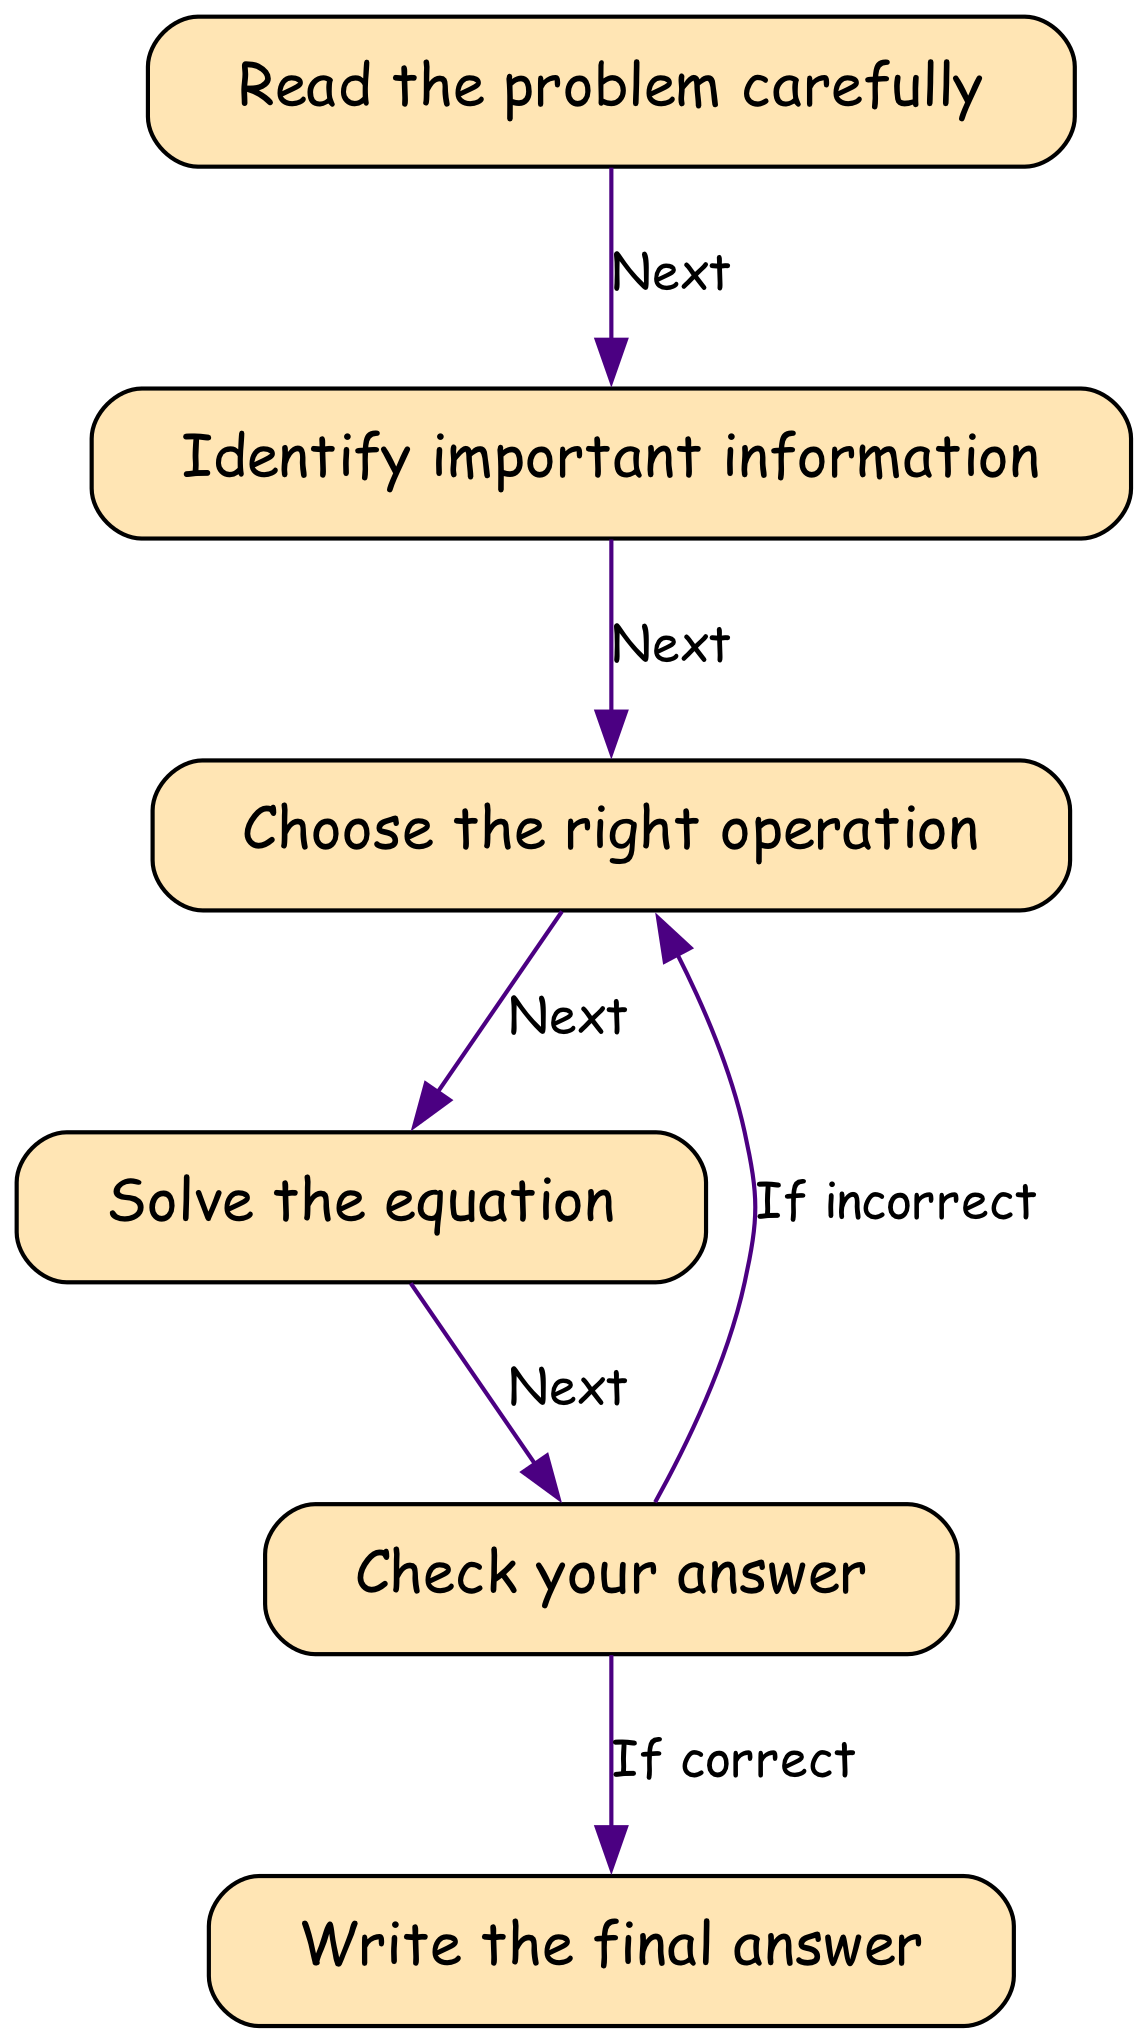What is the first step in the flowchart? The first node in the flowchart is labeled "Read the problem carefully," indicating the initial action to take when solving a math word problem.
Answer: Read the problem carefully How many total nodes are in the diagram? By counting each distinct node in the flowchart, we identify six nodes: start, identify, choose, solve, check, and end.
Answer: Six What does the edge from 'check' to 'end' indicate? The edge labeled "If correct" coming from the 'check' node leads to 'end,' which signifies that if the answer checked is correct, the final step is reached.
Answer: If correct Which node is connected to 'solve'? The 'solve' node is connected from the 'choose' node, indicating that solving the equation follows after choosing the right operation.
Answer: Choose the right operation What happens if the answer is incorrect in the flowchart? If the answer is incorrect, the flowchart shows that we must go back to the 'choose' node to select the right operation again for correction.
Answer: Choose the right operation What is the final action in the flowchart? The last node in the flowchart is labeled "Write the final answer," which signifies that recording the answer is the concluding action in the process.
Answer: Write the final answer What is the purpose of the 'identify' node? The 'identify' node focuses on recognizing important information within the word problem, setting the foundation for solving it accurately.
Answer: Identify important information Which nodes are directly connected to the 'check' node? The 'check' node has edges connecting it to both the 'end' and 'choose' nodes, showing two possible outcomes based on whether the answer is correct or incorrect.
Answer: End and Choose What sequence of nodes does the flowchart follow after reading the problem? The sequence after reading the problem flows from 'start' to 'identify,' then to 'choose,' followed by 'solve,' and leads to 'check.'
Answer: Identify, choose, solve, check 